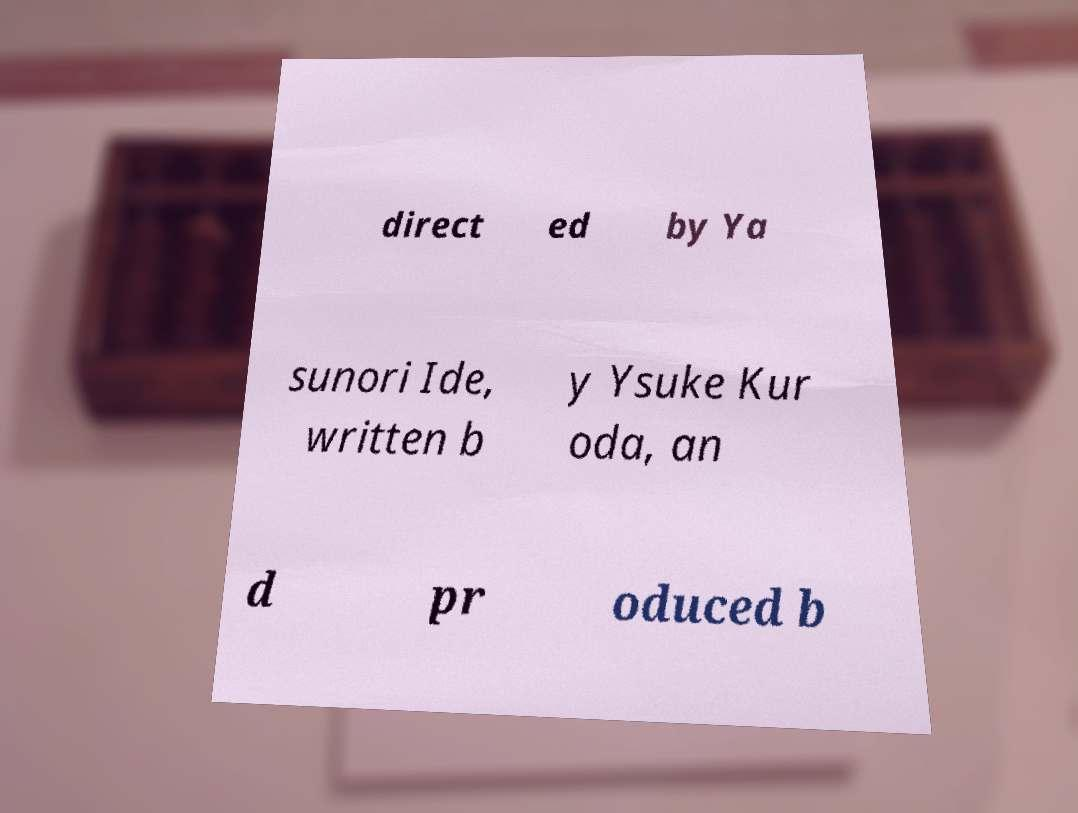Please identify and transcribe the text found in this image. direct ed by Ya sunori Ide, written b y Ysuke Kur oda, an d pr oduced b 